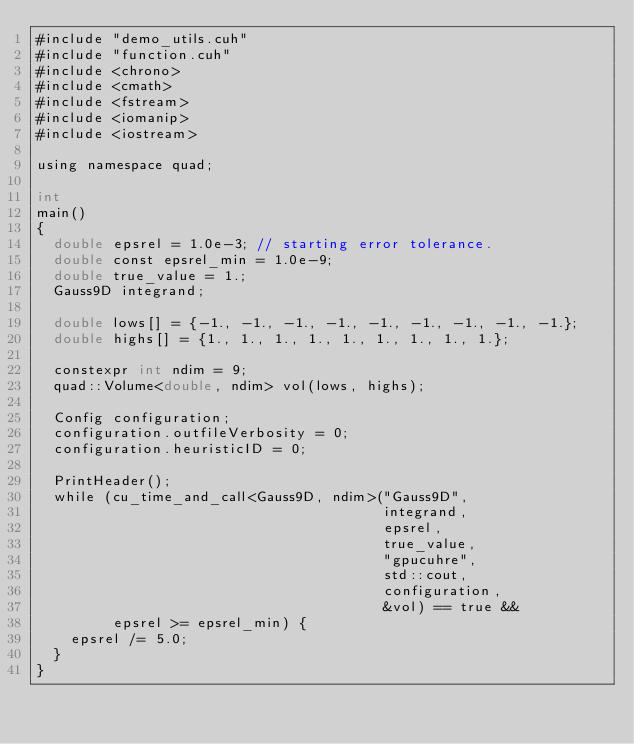<code> <loc_0><loc_0><loc_500><loc_500><_Cuda_>#include "demo_utils.cuh"
#include "function.cuh"
#include <chrono>
#include <cmath>
#include <fstream>
#include <iomanip>
#include <iostream>

using namespace quad;

int
main()
{
  double epsrel = 1.0e-3; // starting error tolerance.
  double const epsrel_min = 1.0e-9;
  double true_value = 1.;
  Gauss9D integrand;

  double lows[] = {-1., -1., -1., -1., -1., -1., -1., -1., -1.};
  double highs[] = {1., 1., 1., 1., 1., 1., 1., 1., 1.};

  constexpr int ndim = 9;
  quad::Volume<double, ndim> vol(lows, highs);

  Config configuration;
  configuration.outfileVerbosity = 0;
  configuration.heuristicID = 0;

  PrintHeader();
  while (cu_time_and_call<Gauss9D, ndim>("Gauss9D",
                                         integrand,
                                         epsrel,
                                         true_value,
                                         "gpucuhre",
                                         std::cout,
                                         configuration,
                                         &vol) == true &&
         epsrel >= epsrel_min) {
    epsrel /= 5.0;
  }
}
</code> 